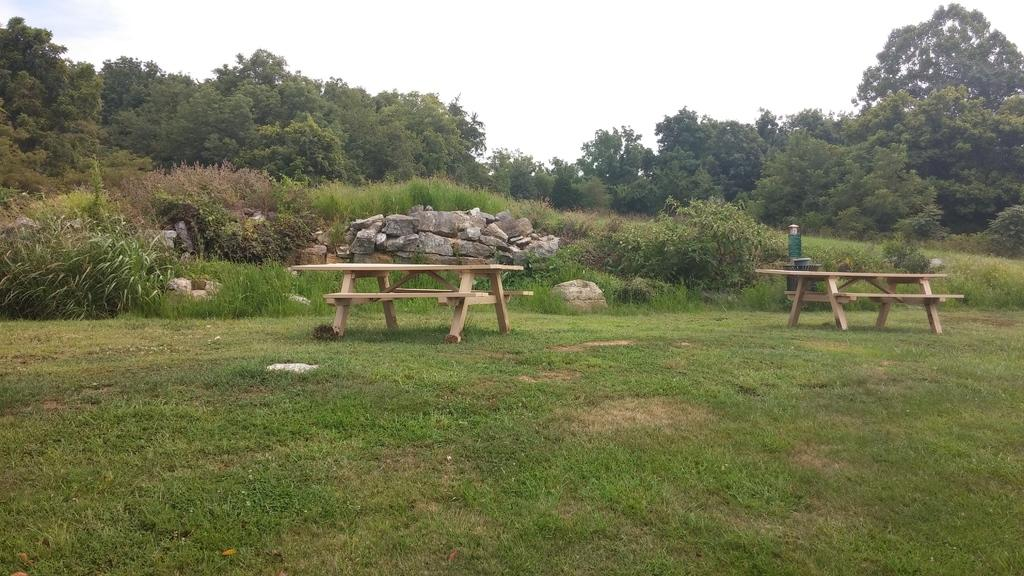What type of seating is available on the grass in the image? There are benches on the grass in the image. What can be seen in the background of the image? In the background, there are stones, trees, plants, grass, and the sky. How is the grass represented in the image? Grass is present at the bottom of the image and in the background. What type of quill is being used to write on the grass in the image? There is no quill or writing activity present in the image. How does the neck of the person sitting on the bench appear in the image? There is no person or neck visible in the image; only benches, grass, and background elements are present. 